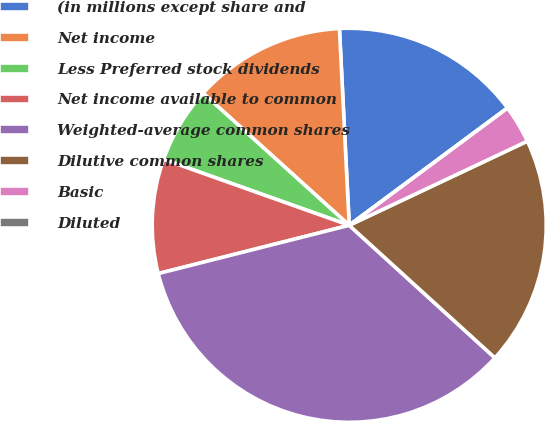Convert chart to OTSL. <chart><loc_0><loc_0><loc_500><loc_500><pie_chart><fcel>(in millions except share and<fcel>Net income<fcel>Less Preferred stock dividends<fcel>Net income available to common<fcel>Weighted-average common shares<fcel>Dilutive common shares<fcel>Basic<fcel>Diluted<nl><fcel>15.64%<fcel>12.51%<fcel>6.26%<fcel>9.38%<fcel>34.31%<fcel>18.77%<fcel>3.13%<fcel>0.0%<nl></chart> 